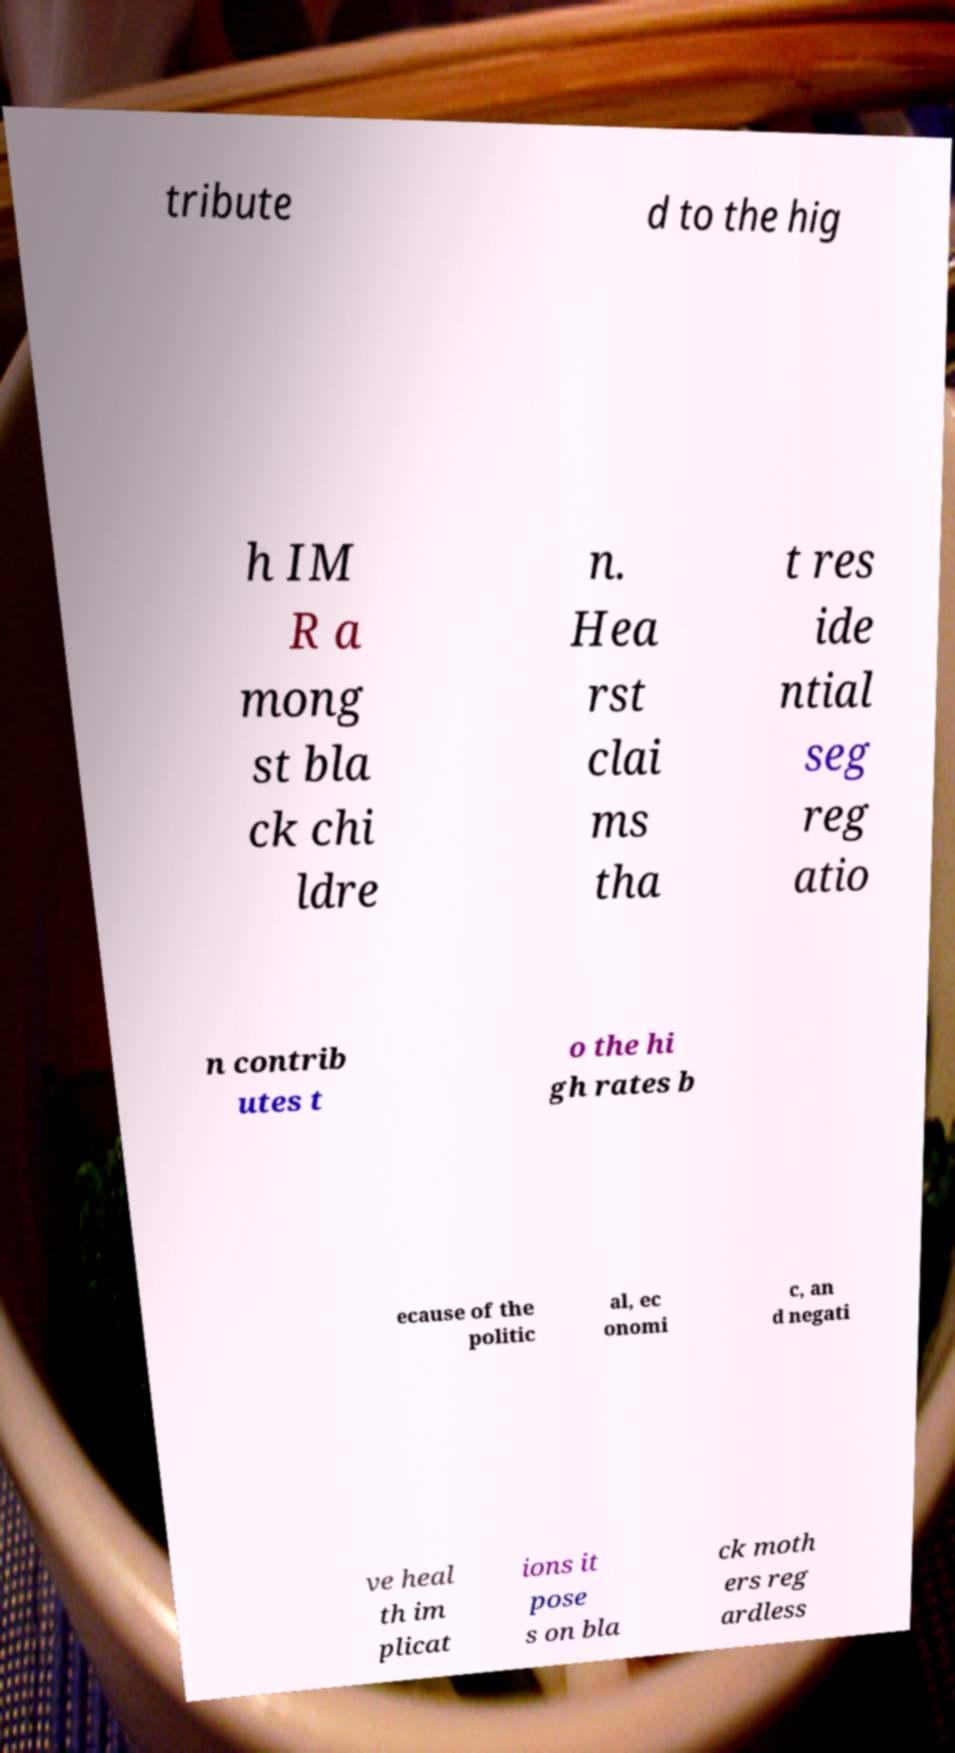For documentation purposes, I need the text within this image transcribed. Could you provide that? tribute d to the hig h IM R a mong st bla ck chi ldre n. Hea rst clai ms tha t res ide ntial seg reg atio n contrib utes t o the hi gh rates b ecause of the politic al, ec onomi c, an d negati ve heal th im plicat ions it pose s on bla ck moth ers reg ardless 